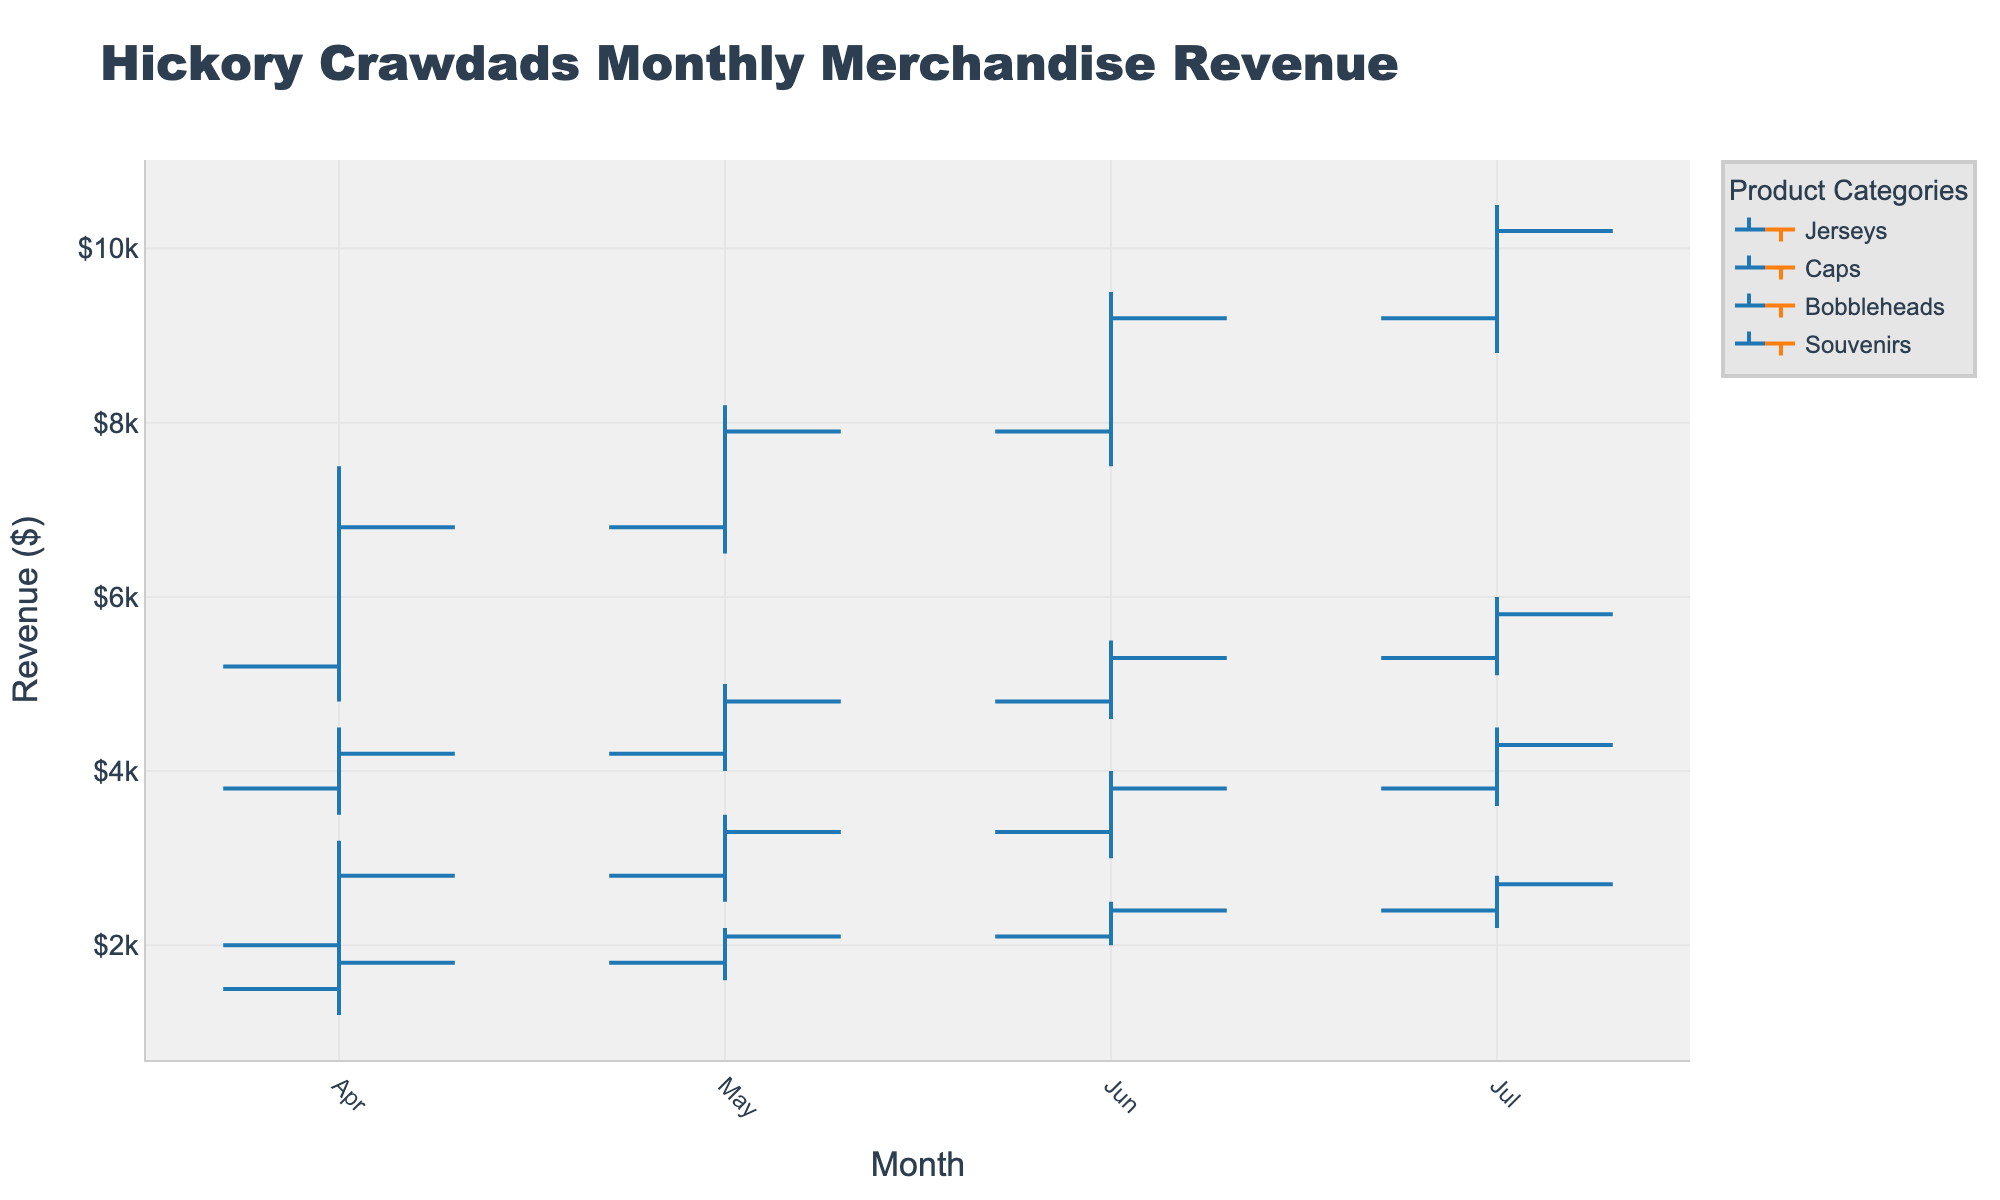What's the title of the figure? The title of a figure is typically found at the top and directly indicates what the chart represents.
Answer: Hickory Crawdads Monthly Merchandise Revenue Which category had the highest revenue in July? By examining the 'High' value for each category in July, the category with the highest number is chosen. Jerseys has the highest revenue with a peak of $10500.
Answer: Jerseys What was the closing revenue for Caps in May? The 'Close' value represents the closing revenue for a given month and category. For May Caps, this value is $4800.
Answer: $4800 What is the lowest revenue recorded for Bobbleheads across all months? The 'Low' value illustrates the lowest revenue each month. The lowest value for Bobbleheads across all months is $1800 in April.
Answer: $1800 Compare the closing revenue for Souvenirs between May and June. The closing revenues for Souvenirs in May and June are $2100 and $2400, respectively. By comparing these numbers, $2400 (June) is greater than $2100 (May).
Answer: $2400 (June) > $2100 (May) Which month showed the highest increase in revenue for Jerseys from the opening to closing value? To find the largest increase, subtract each month's 'Open' from 'Close' for Jerseys. April: 6800-5200=1600, May: 7900-6800=1100, June: 9200-7900=1300, July: 10200-9200=1000. April has the highest increase of $1600.
Answer: April Did any category have a decreasing revenue trend from June to July? Look at the 'Close' values from June to July. Jerseys: 9200 to 10200, Caps: 5300 to 5800, Bobbleheads: 3800 to 4300, Souvenirs: 2400 to 2700. No category shows a decreasing trend, all increased.
Answer: No What is the average high revenue for Caps over the four months? Sum up the 'High' values for Caps (4500+5000+5500+6000=21000) and divide by the number of months (4). 21000/4 gives an average high revenue of $5250.
Answer: $5250 Which category had the highest volatility in April? Volatility can be observed by range (High-Low). April ranges are: Jerseys: 7500-4800=2700, Caps: 4500-3500=1000, Bobbleheads: 3200-1800=1400, Souvenirs: 2000-1200=800. Jerseys had the highest volatility.
Answer: Jerseys What is the sum of the closing revenues for all categories in July? Add up all 'Close' values for July: Jerseys 10200 + Caps 5800 + Bobbleheads 4300 + Souvenirs 2700. The sum is 23000.
Answer: $23000 